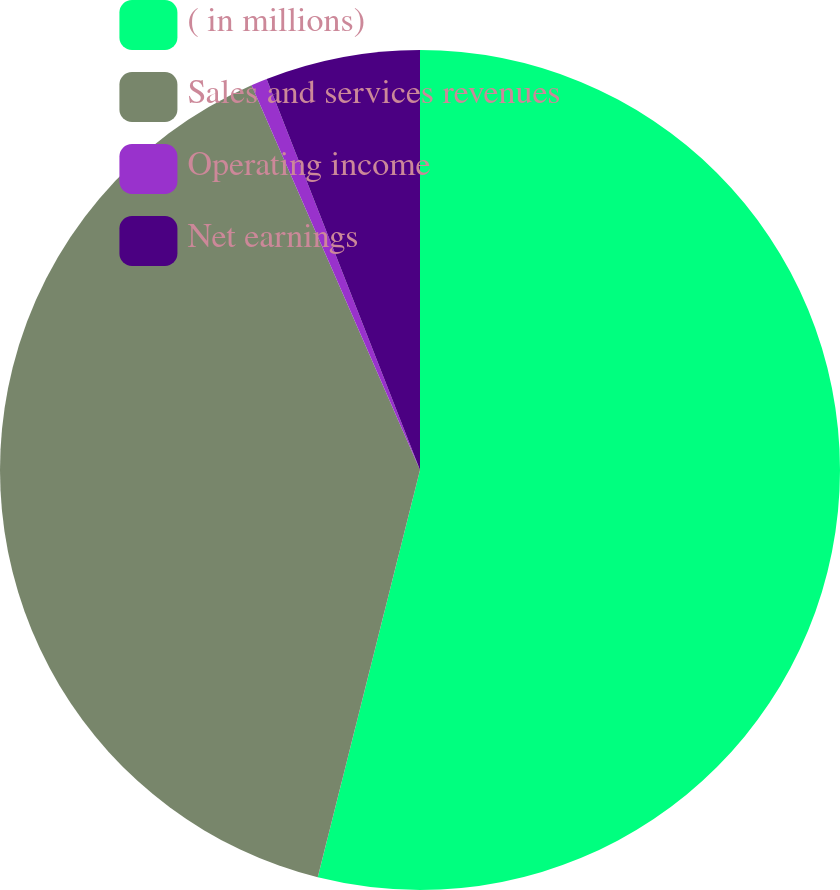<chart> <loc_0><loc_0><loc_500><loc_500><pie_chart><fcel>( in millions)<fcel>Sales and services revenues<fcel>Operating income<fcel>Net earnings<nl><fcel>53.92%<fcel>39.52%<fcel>0.62%<fcel>5.95%<nl></chart> 